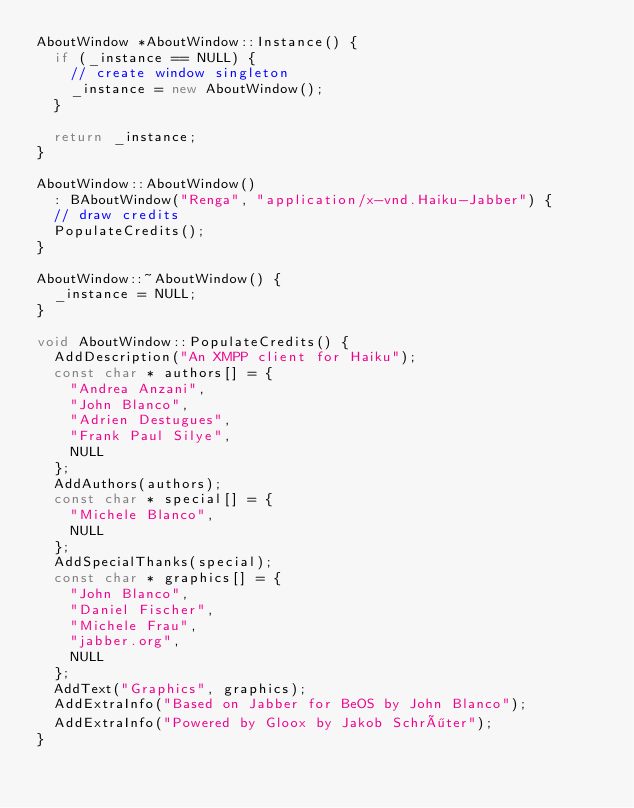Convert code to text. <code><loc_0><loc_0><loc_500><loc_500><_C++_>AboutWindow *AboutWindow::Instance() {
	if (_instance == NULL) {
		// create window singleton
		_instance = new AboutWindow();
	}

	return _instance;
}

AboutWindow::AboutWindow()
	: BAboutWindow("Renga", "application/x-vnd.Haiku-Jabber") {
	// draw credits
	PopulateCredits();
}

AboutWindow::~AboutWindow() {
	_instance = NULL;
}
	
void AboutWindow::PopulateCredits() {
	AddDescription("An XMPP client for Haiku");
	const char * authors[] = {
		"Andrea Anzani",
		"John Blanco",
		"Adrien Destugues",
		"Frank Paul Silye",
		NULL
	};
	AddAuthors(authors);
	const char * special[] = {
		"Michele Blanco",
		NULL
	};
	AddSpecialThanks(special);
	const char * graphics[] = {
		"John Blanco",
		"Daniel Fischer",
		"Michele Frau",
		"jabber.org",
		NULL
	};
	AddText("Graphics", graphics);
	AddExtraInfo("Based on Jabber for BeOS by John Blanco");
	AddExtraInfo("Powered by Gloox by Jakob Schröter");
}

</code> 